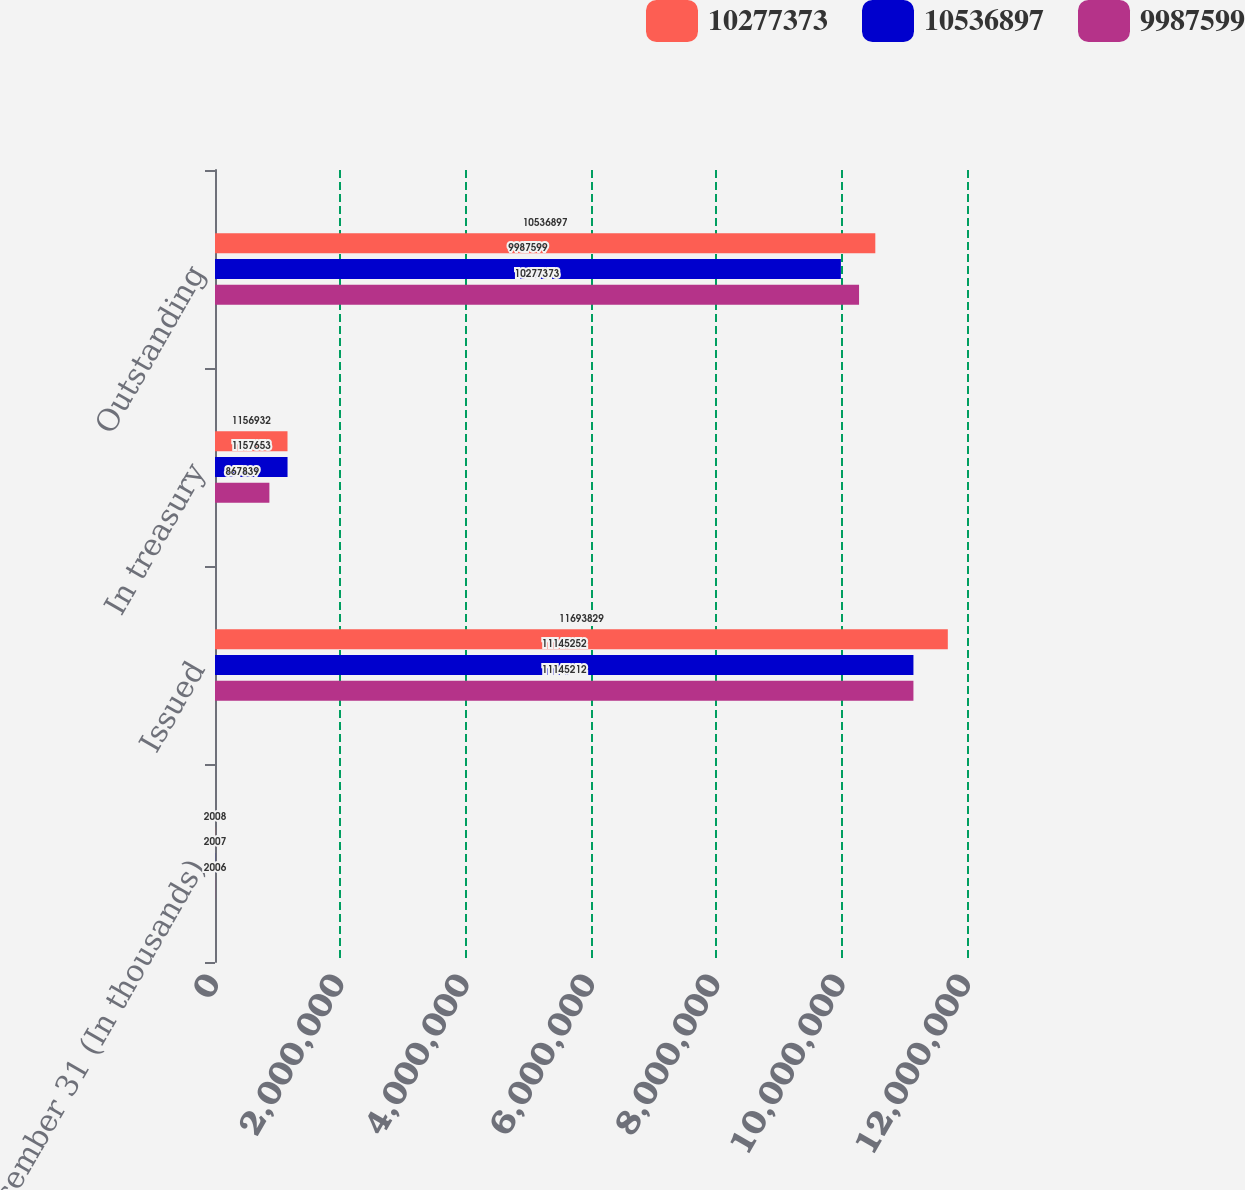Convert chart to OTSL. <chart><loc_0><loc_0><loc_500><loc_500><stacked_bar_chart><ecel><fcel>December 31 (In thousands)<fcel>Issued<fcel>In treasury<fcel>Outstanding<nl><fcel>1.02774e+07<fcel>2008<fcel>1.16938e+07<fcel>1.15693e+06<fcel>1.05369e+07<nl><fcel>1.05369e+07<fcel>2007<fcel>1.11453e+07<fcel>1.15765e+06<fcel>9.9876e+06<nl><fcel>9.9876e+06<fcel>2006<fcel>1.11452e+07<fcel>867839<fcel>1.02774e+07<nl></chart> 